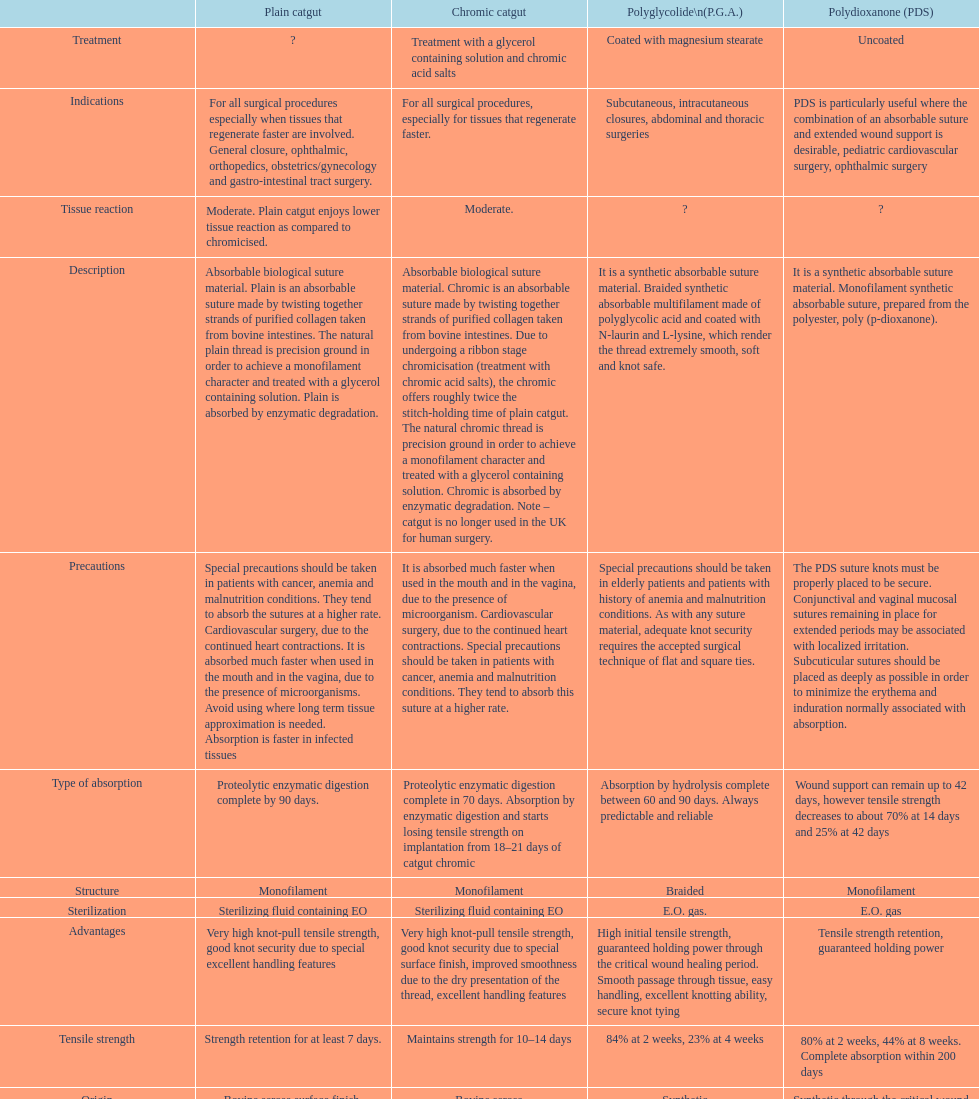The plain catgut maintains its strength for at least how many number of days? Strength retention for at least 7 days. 